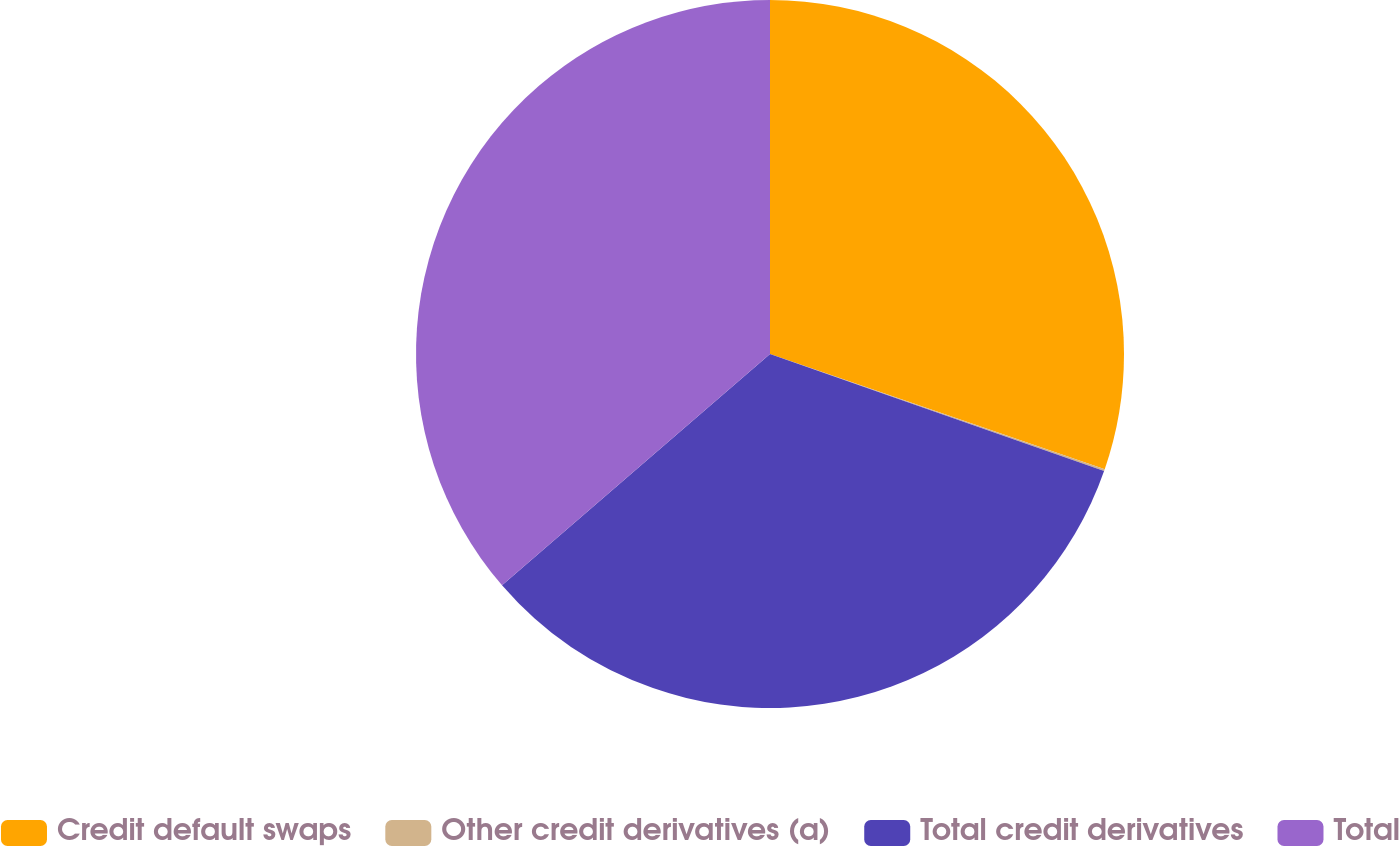<chart> <loc_0><loc_0><loc_500><loc_500><pie_chart><fcel>Credit default swaps<fcel>Other credit derivatives (a)<fcel>Total credit derivatives<fcel>Total<nl><fcel>30.27%<fcel>0.09%<fcel>33.3%<fcel>36.33%<nl></chart> 